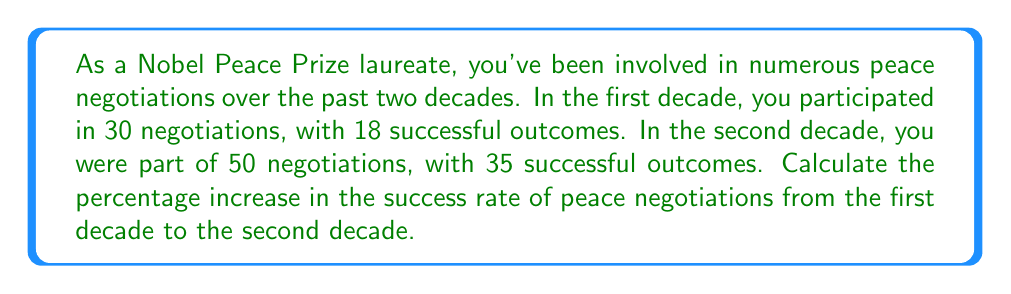Can you answer this question? To solve this problem, we need to follow these steps:

1. Calculate the success rate for each decade:

   First decade:
   $\text{Success rate}_1 = \frac{\text{Successful negotiations}}{\text{Total negotiations}} \times 100\%$
   $\text{Success rate}_1 = \frac{18}{30} \times 100\% = 60\%$

   Second decade:
   $\text{Success rate}_2 = \frac{\text{Successful negotiations}}{\text{Total negotiations}} \times 100\%$
   $\text{Success rate}_2 = \frac{35}{50} \times 100\% = 70\%$

2. Calculate the percentage increase:

   $\text{Percentage increase} = \frac{\text{Increase in value}}{\text{Original value}} \times 100\%$

   $\text{Increase in value} = \text{Success rate}_2 - \text{Success rate}_1 = 70\% - 60\% = 10\%$

   $\text{Percentage increase} = \frac{10\%}{60\%} \times 100\% = \frac{1}{6} \times 100\% \approx 16.67\%$

Therefore, the percentage increase in the success rate of peace negotiations from the first decade to the second decade is approximately 16.67%.
Answer: The percentage increase in the success rate of peace negotiations from the first decade to the second decade is approximately 16.67%. 